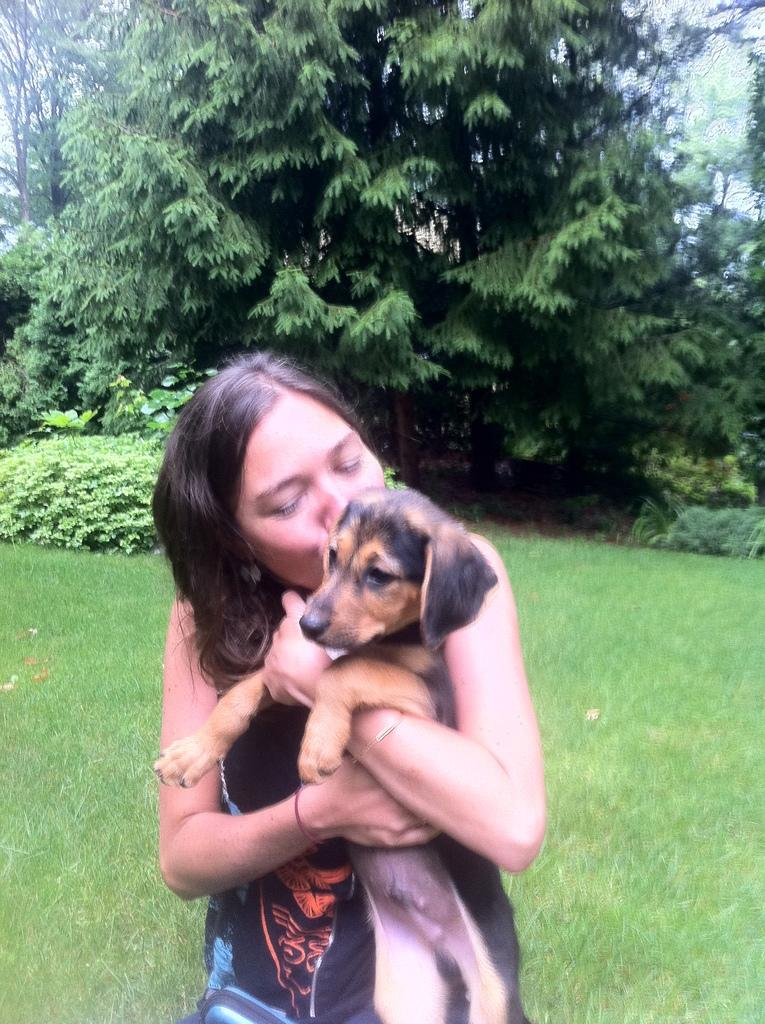Who is the main subject in the image? There is a woman in the image. What is the woman holding in the image? The woman is holding a dog. What can be seen in the background of the image? There are trees in the background of the image. What type of development can be seen in the image? There is no development project or construction site present in the image; it features a woman holding a dog with trees in the background. 